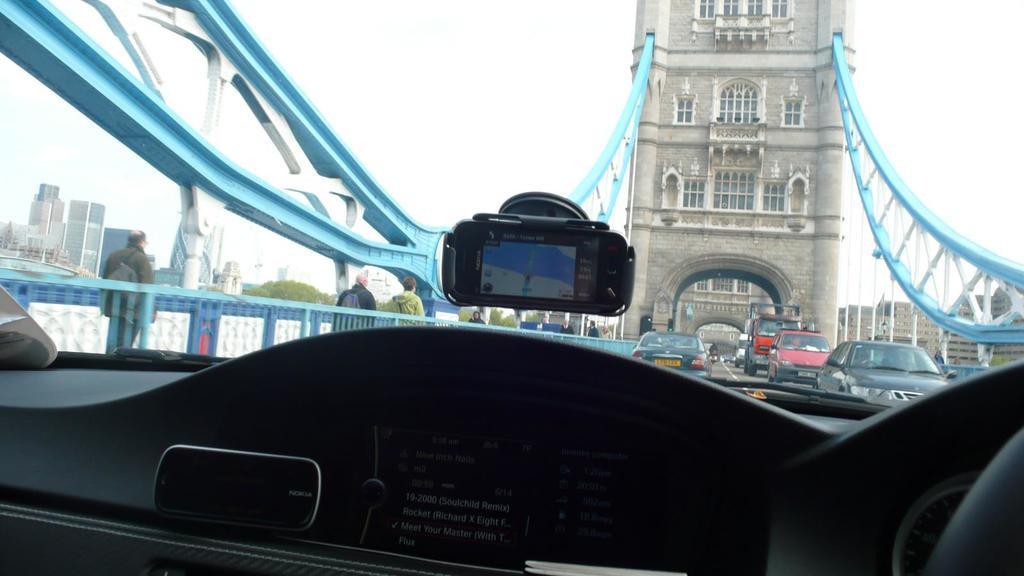In one or two sentences, can you explain what this image depicts? In this image we can see an interior of a vehicle. In the vehicle we can see a screen on which we have some text. On the glass of the vehicle an object is attached and on the object screen we can see the navigation. Through the glass we can see vehicles, bridge and buildings. On the left side, we can see a fencing, persons, building and trees. On the right side, we can see the buildings. At the top we can see the sky. 